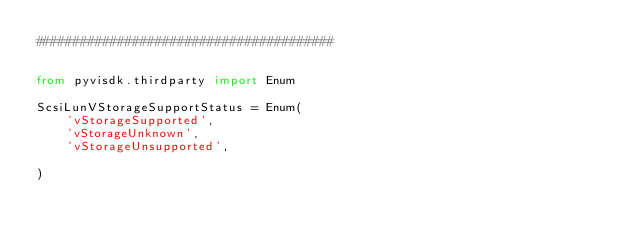Convert code to text. <code><loc_0><loc_0><loc_500><loc_500><_Python_>########################################


from pyvisdk.thirdparty import Enum

ScsiLunVStorageSupportStatus = Enum(
    'vStorageSupported',
    'vStorageUnknown',
    'vStorageUnsupported',

)
</code> 